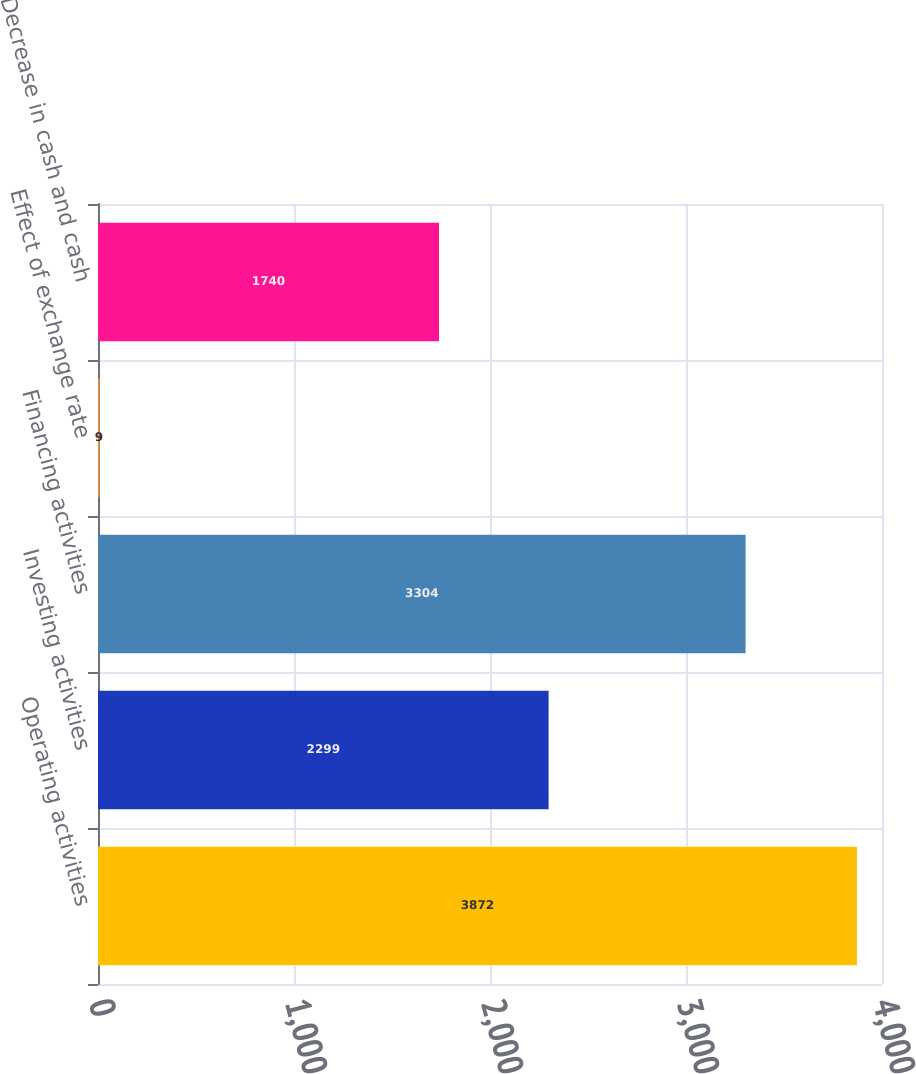Convert chart. <chart><loc_0><loc_0><loc_500><loc_500><bar_chart><fcel>Operating activities<fcel>Investing activities<fcel>Financing activities<fcel>Effect of exchange rate<fcel>Decrease in cash and cash<nl><fcel>3872<fcel>2299<fcel>3304<fcel>9<fcel>1740<nl></chart> 